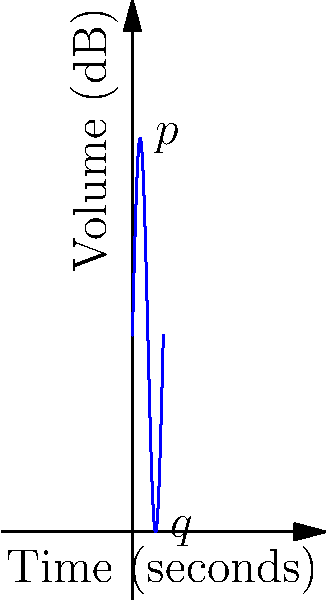As you analyze a rare piece from your partner's collection, you notice the dynamics follow a sinusoidal pattern. The graph represents the volume over time, where the volume (in decibels) is given by the function $V(t) = 40 + 40\sin(t)$, with $t$ in seconds. At what point in the cycle is the rate of change in volume the greatest, and what is this maximum rate of change? To find the point of greatest rate of change and its value, we need to follow these steps:

1) The rate of change is given by the derivative of the function. Let's find $V'(t)$:
   $V'(t) = 40\cos(t)$

2) The maximum rate of change occurs where $|V'(t)|$ is at its maximum.
   The maximum value of cosine is 1, which occurs when $t = 0, 2\pi, 4\pi,$ etc.
   The minimum value is -1, which occurs when $t = \pi, 3\pi,$ etc.

3) Therefore, the maximum rate of change in absolute terms occurs at these points, with a value of:
   $|V'(t)| = |40\cos(t)| = 40$ dB/s

4) On the given graph, this corresponds to the points where the curve crosses the middle line (40 dB).
   These are the inflection points of the sine curve, occurring at $t = 0, \pi, 2\pi,$ etc.

5) The positive maximum rate of change (increasing volume) occurs at $t = 0, 2\pi,$ etc., corresponding to point $q$ on the graph.
   The negative maximum rate of change (decreasing volume) occurs at $t = \pi, 3\pi,$ etc., corresponding to point $p$ on the graph.
Answer: Maximum rate of change: 40 dB/s, occurring at $t = 0, \pi, 2\pi,$ etc. (points $p$ and $q$) 